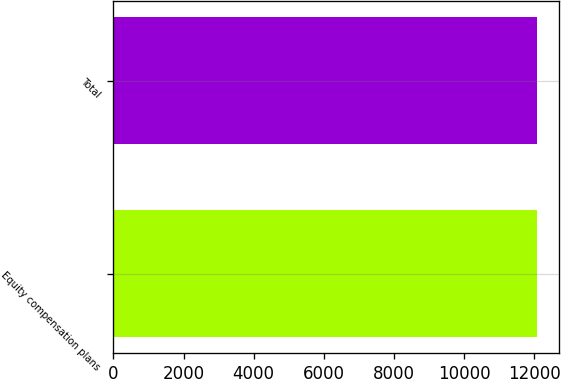<chart> <loc_0><loc_0><loc_500><loc_500><bar_chart><fcel>Equity compensation plans<fcel>Total<nl><fcel>12095<fcel>12095.1<nl></chart> 